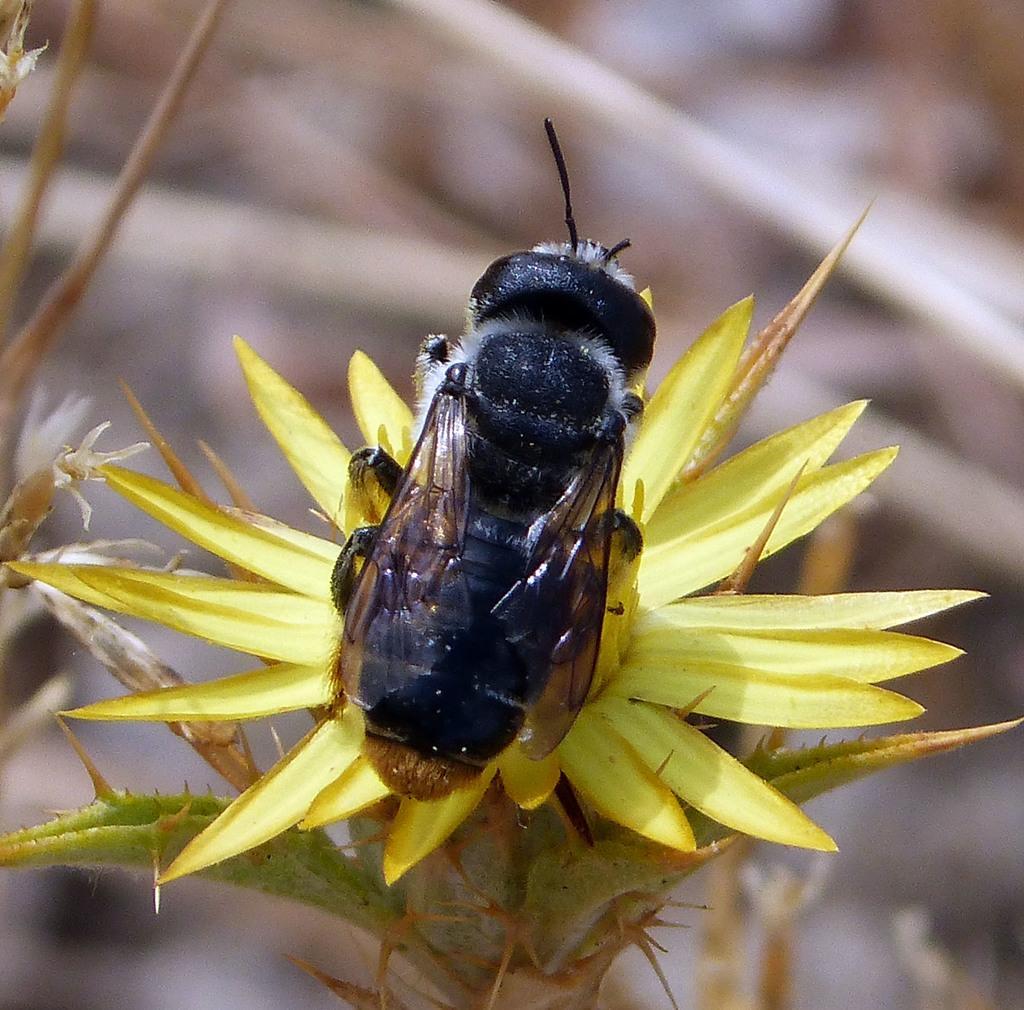Can you describe this image briefly? The picture consists of a bee on a yellow color flower. The background is blurred. 